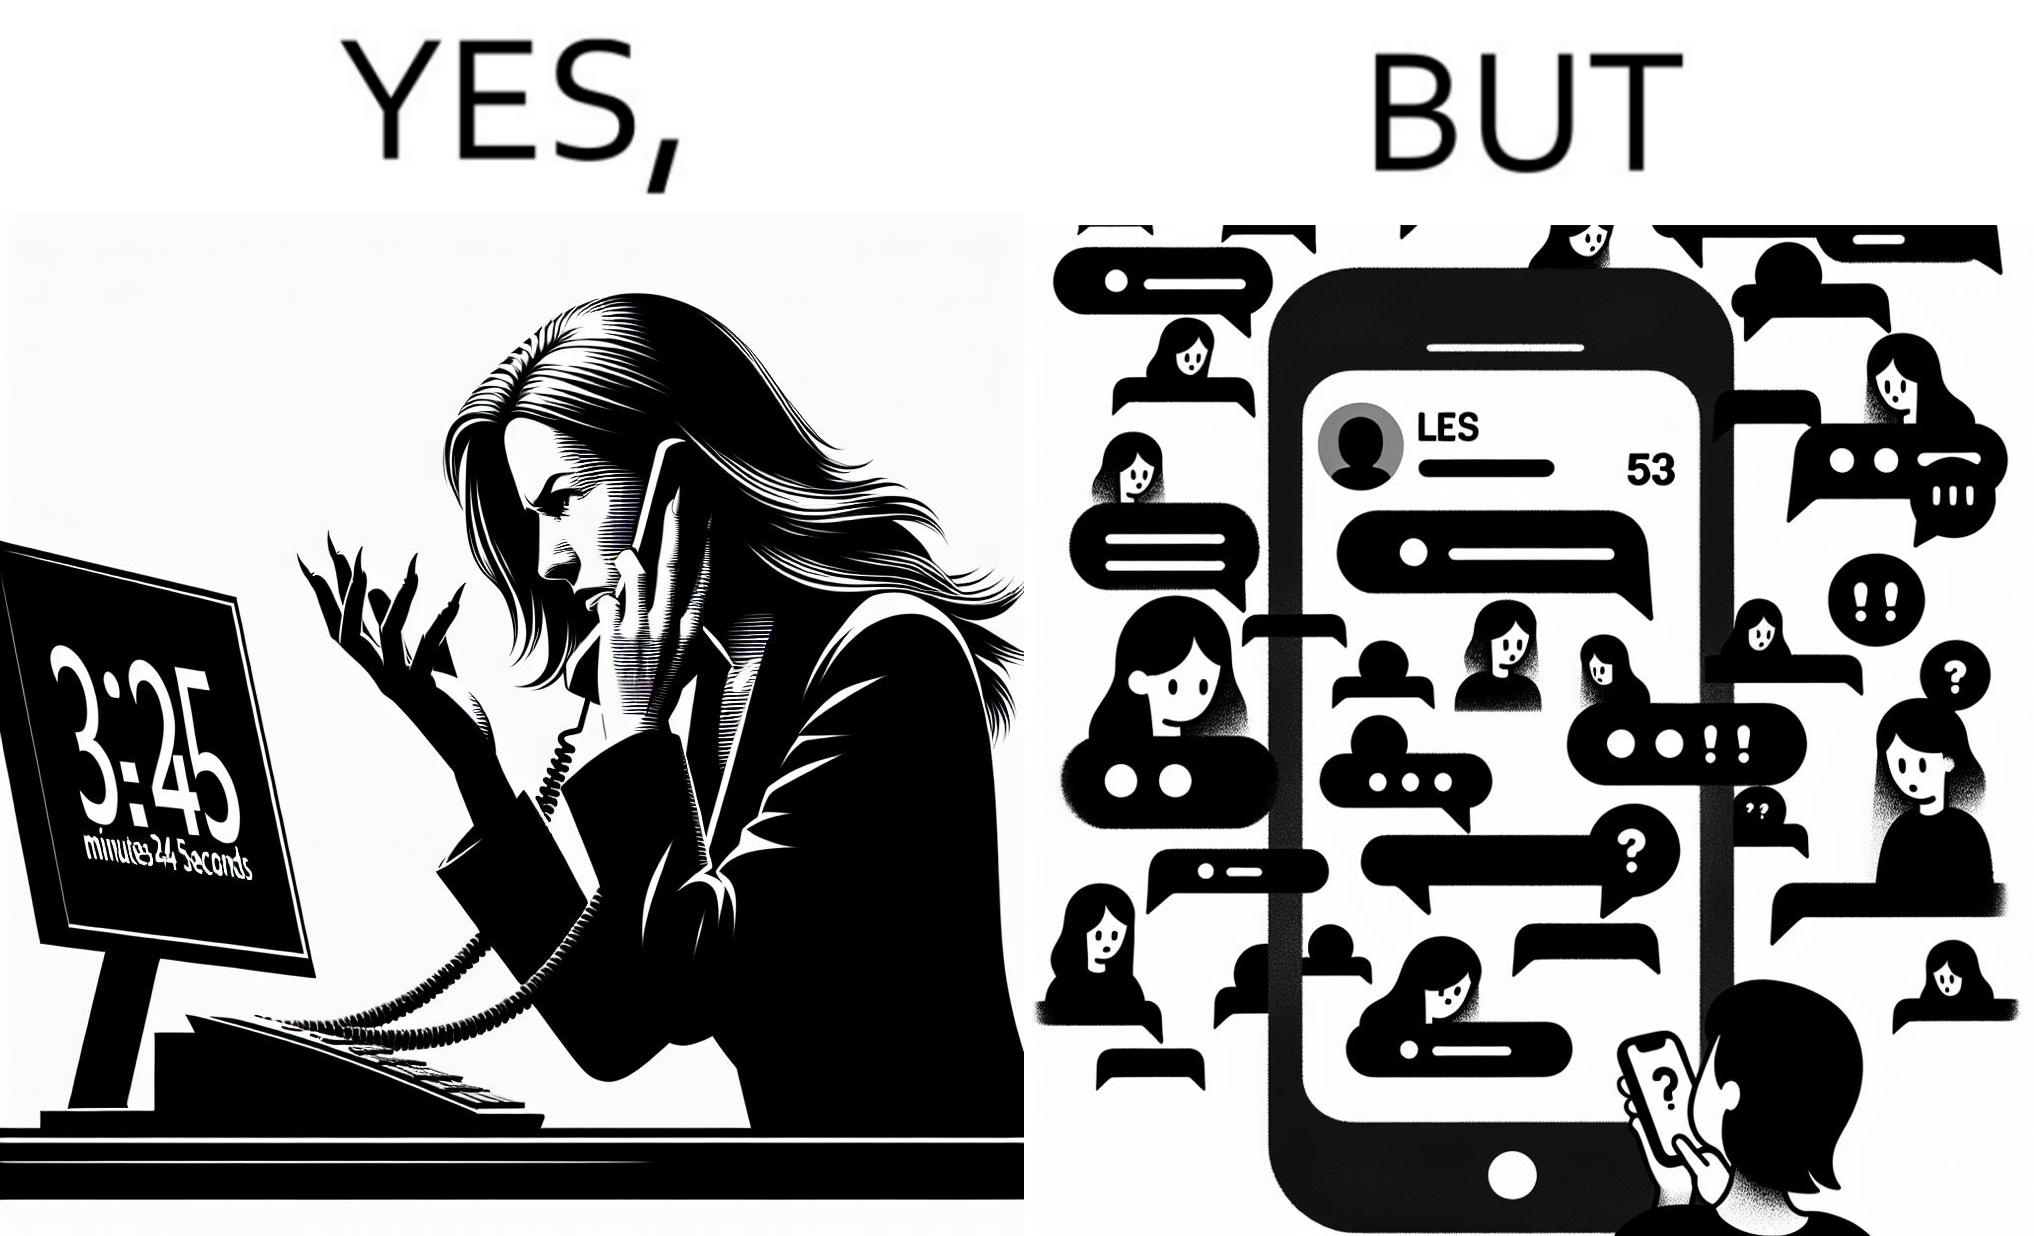Why is this image considered satirical? The image is ironical because while the woman is annoyed by the unresponsiveness of the call center, she herself is being unresponsive to many people in the chat. 